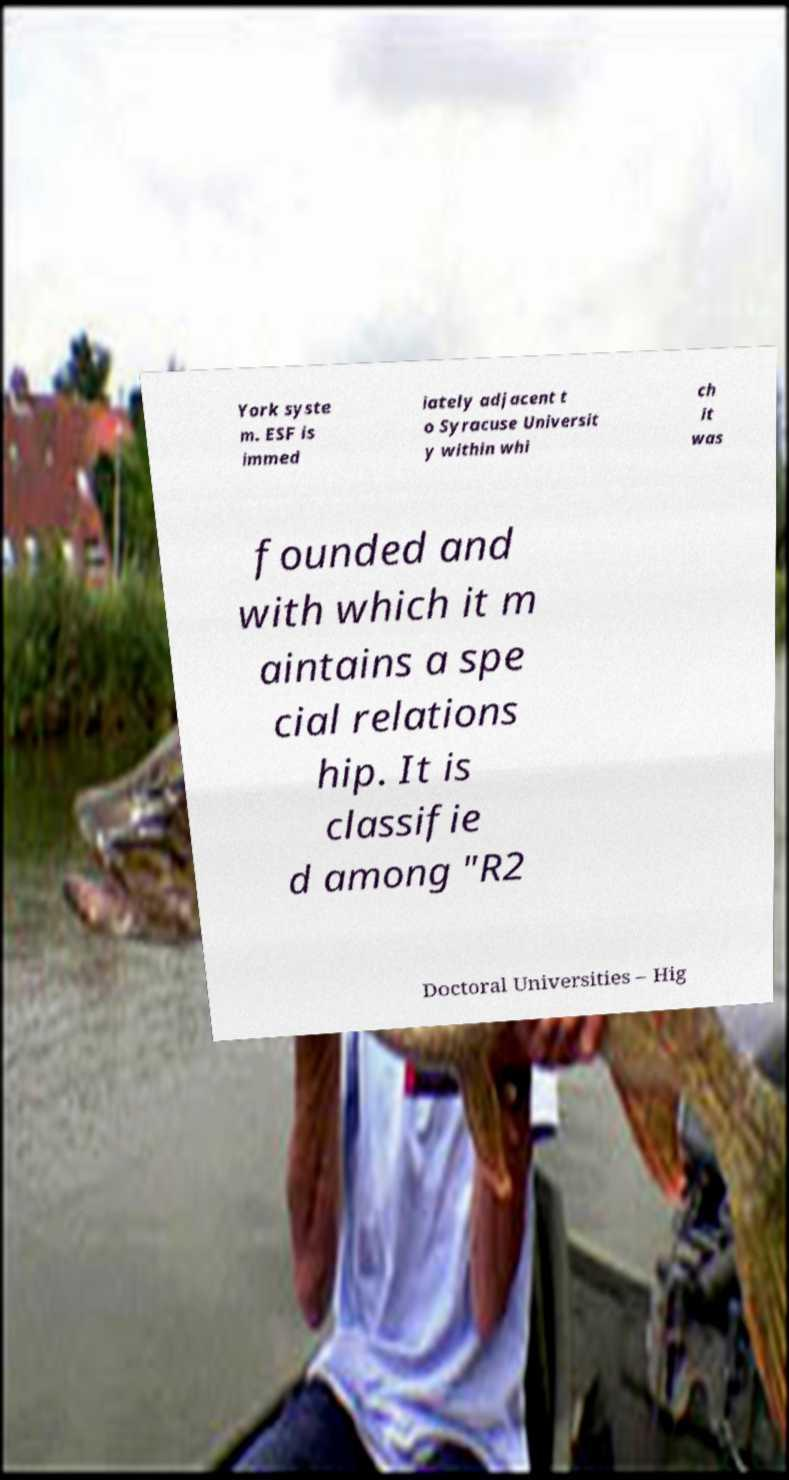Could you assist in decoding the text presented in this image and type it out clearly? York syste m. ESF is immed iately adjacent t o Syracuse Universit y within whi ch it was founded and with which it m aintains a spe cial relations hip. It is classifie d among "R2 Doctoral Universities – Hig 